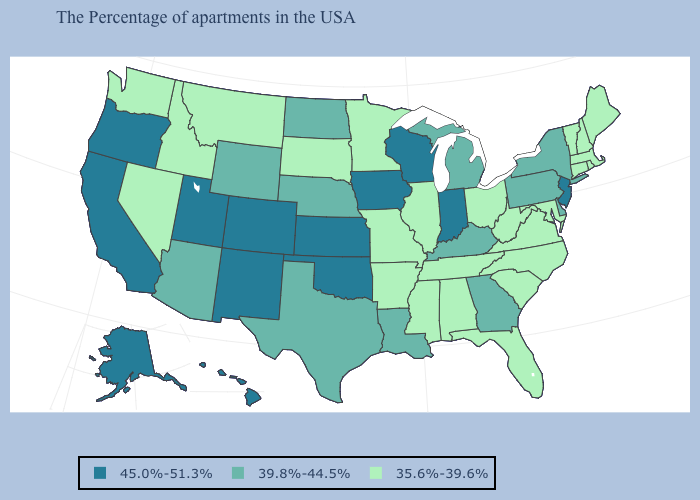Which states have the highest value in the USA?
Be succinct. New Jersey, Indiana, Wisconsin, Iowa, Kansas, Oklahoma, Colorado, New Mexico, Utah, California, Oregon, Alaska, Hawaii. Does Delaware have the same value as North Dakota?
Answer briefly. Yes. Does California have the same value as New Jersey?
Give a very brief answer. Yes. What is the highest value in the USA?
Keep it brief. 45.0%-51.3%. Does Oregon have the lowest value in the USA?
Answer briefly. No. What is the value of Maryland?
Give a very brief answer. 35.6%-39.6%. What is the value of Virginia?
Answer briefly. 35.6%-39.6%. Name the states that have a value in the range 45.0%-51.3%?
Concise answer only. New Jersey, Indiana, Wisconsin, Iowa, Kansas, Oklahoma, Colorado, New Mexico, Utah, California, Oregon, Alaska, Hawaii. Among the states that border Florida , which have the highest value?
Answer briefly. Georgia. Name the states that have a value in the range 45.0%-51.3%?
Quick response, please. New Jersey, Indiana, Wisconsin, Iowa, Kansas, Oklahoma, Colorado, New Mexico, Utah, California, Oregon, Alaska, Hawaii. Among the states that border Delaware , which have the lowest value?
Concise answer only. Maryland. Among the states that border Georgia , which have the highest value?
Be succinct. North Carolina, South Carolina, Florida, Alabama, Tennessee. Does Kansas have the highest value in the USA?
Give a very brief answer. Yes. Among the states that border Illinois , which have the lowest value?
Concise answer only. Missouri. What is the highest value in states that border South Carolina?
Answer briefly. 39.8%-44.5%. 